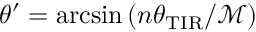Convert formula to latex. <formula><loc_0><loc_0><loc_500><loc_500>\theta ^ { \prime } = \arcsin \left ( n \theta _ { T I R } / \mathcal { M } \right )</formula> 